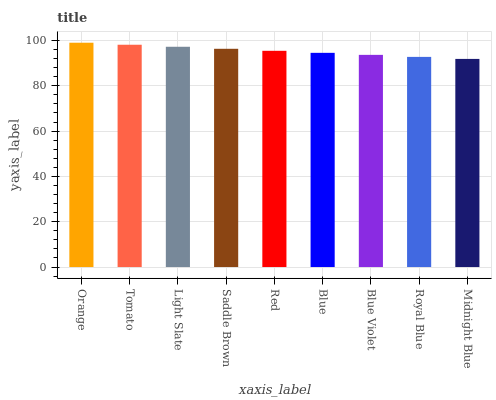Is Midnight Blue the minimum?
Answer yes or no. Yes. Is Orange the maximum?
Answer yes or no. Yes. Is Tomato the minimum?
Answer yes or no. No. Is Tomato the maximum?
Answer yes or no. No. Is Orange greater than Tomato?
Answer yes or no. Yes. Is Tomato less than Orange?
Answer yes or no. Yes. Is Tomato greater than Orange?
Answer yes or no. No. Is Orange less than Tomato?
Answer yes or no. No. Is Red the high median?
Answer yes or no. Yes. Is Red the low median?
Answer yes or no. Yes. Is Blue Violet the high median?
Answer yes or no. No. Is Blue the low median?
Answer yes or no. No. 